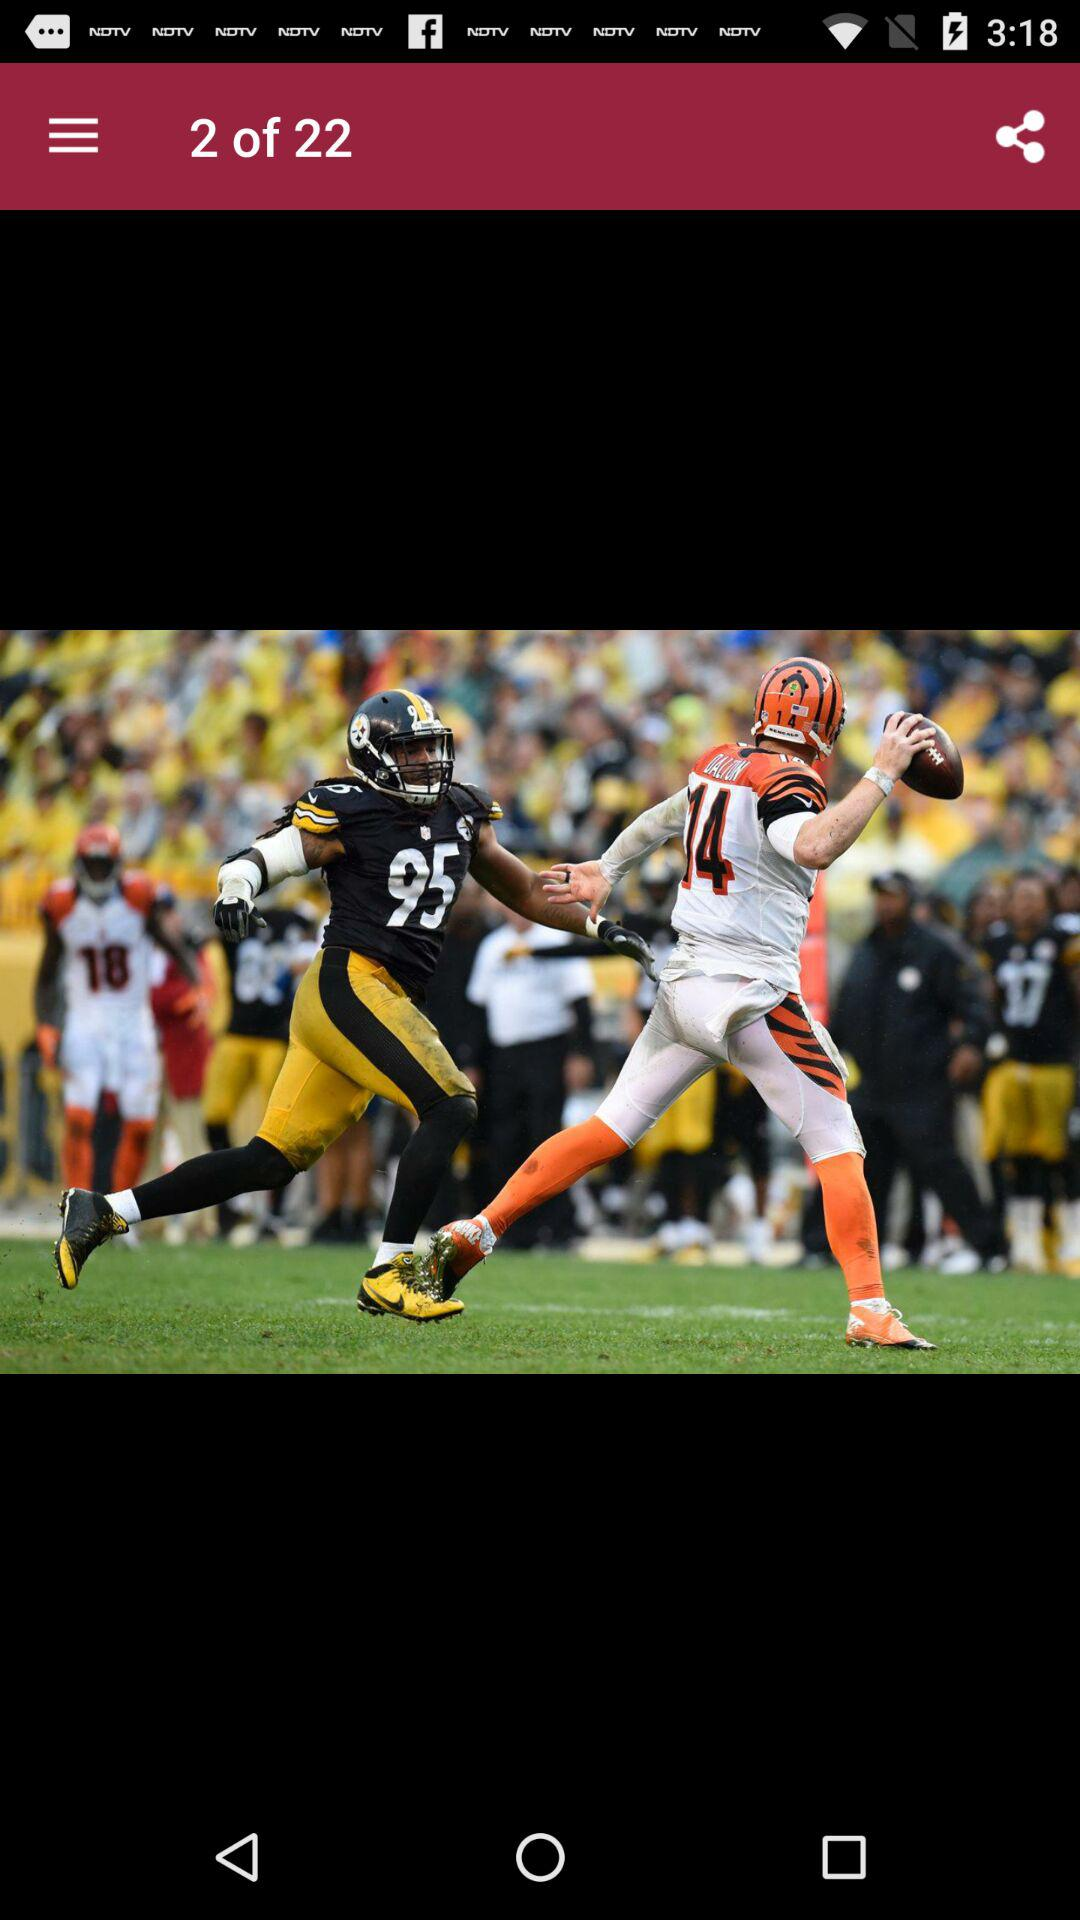What is the current image number? The current image number is 2. 